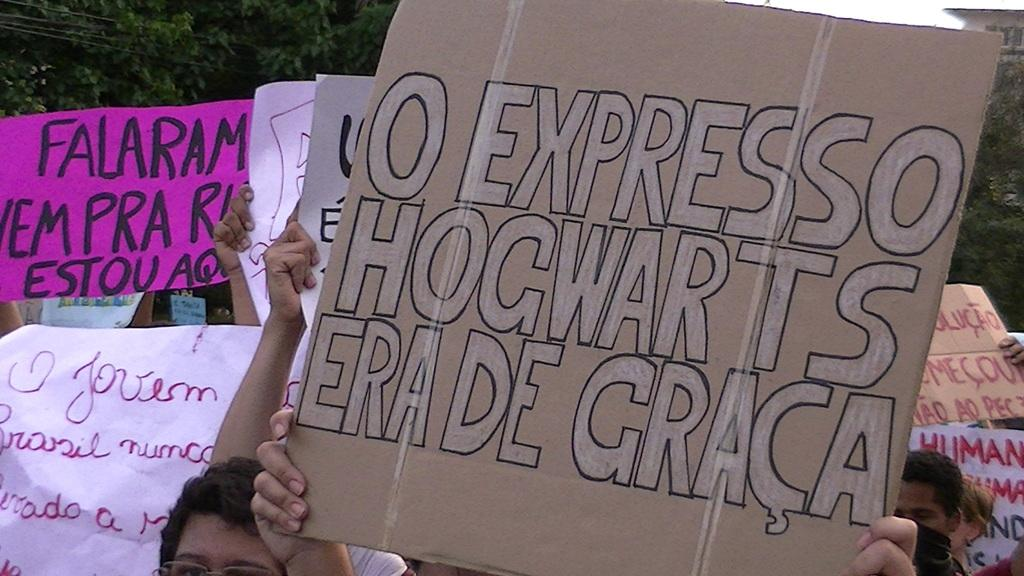What are the people in the image holding? The people in the image are holding boards and banners. What can be read on the boards and banners? Text is visible on the boards and banners. What can be seen in the background of the image? There are many trees in the background of the image. Where is the store located in the image? There is no store present in the image. Can you describe the servant's attire in the image? There are no servants or any attire related to servants in the image. 